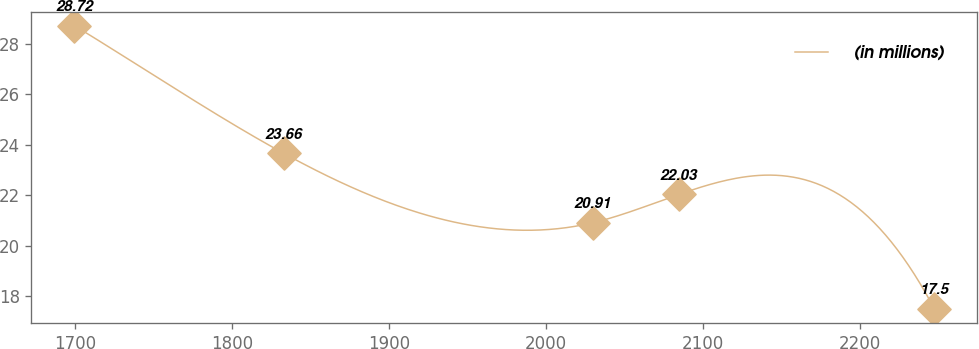Convert chart to OTSL. <chart><loc_0><loc_0><loc_500><loc_500><line_chart><ecel><fcel>(in millions)<nl><fcel>1699.37<fcel>28.72<nl><fcel>1832.78<fcel>23.66<nl><fcel>2029.66<fcel>20.91<nl><fcel>2084.46<fcel>22.03<nl><fcel>2247.35<fcel>17.5<nl></chart> 